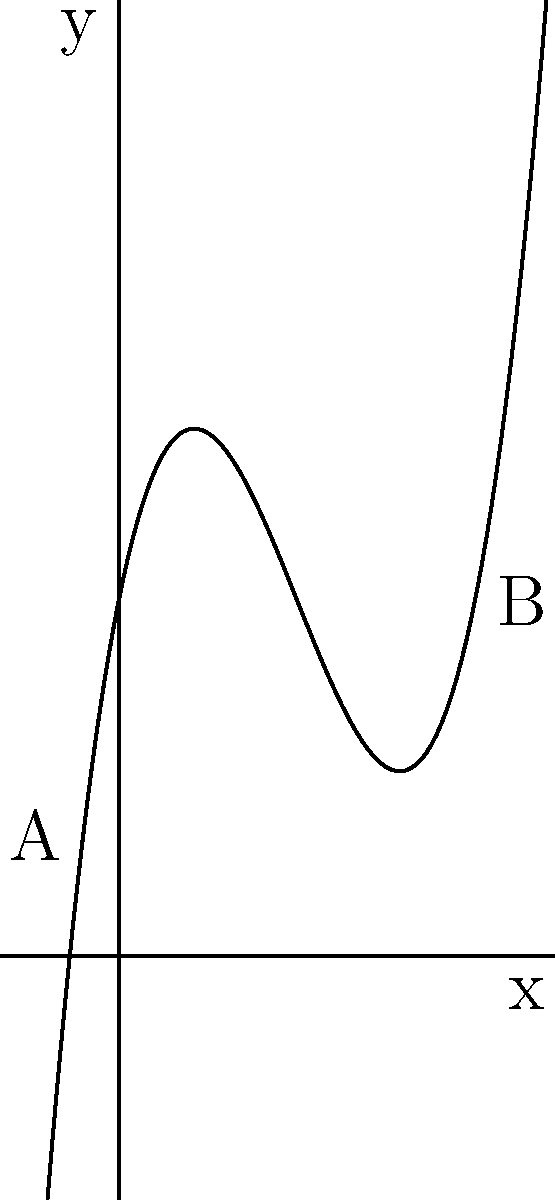The secret underground tunnel system beneath the palace follows a path described by the polynomial function $f(x) = 0.1x^3 - 1.5x^2 + 5x + 10$, where $x$ represents the horizontal distance from the palace entrance in meters, and $f(x)$ represents the depth below ground level in meters. If you need to excavate a vertical shaft to intercept the tunnel at its deepest point between points A and B on the graph, at what horizontal distance from the palace entrance should you start digging? To find the deepest point of the tunnel between points A and B, we need to follow these steps:

1) The deepest point occurs where the derivative of the function is zero. Let's find the derivative:

   $f'(x) = 0.3x^2 - 3x + 5$

2) Set the derivative to zero and solve for x:

   $0.3x^2 - 3x + 5 = 0$

3) This is a quadratic equation. We can solve it using the quadratic formula:

   $x = \frac{-b \pm \sqrt{b^2 - 4ac}}{2a}$

   Where $a = 0.3$, $b = -3$, and $c = 5$

4) Plugging in these values:

   $x = \frac{3 \pm \sqrt{9 - 6}}{0.6} = \frac{3 \pm \sqrt{3}}{0.6}$

5) This gives us two solutions:

   $x_1 = \frac{3 + \sqrt{3}}{0.6} \approx 7.88$ meters
   $x_2 = \frac{3 - \sqrt{3}}{0.6} \approx 2.12$ meters

6) Since we're looking at the section between points A and B, and B is at x = 10, the solution we want is x ≈ 7.88 meters.

Therefore, you should start digging approximately 7.88 meters from the palace entrance to intercept the tunnel at its deepest point between A and B.
Answer: 7.88 meters 